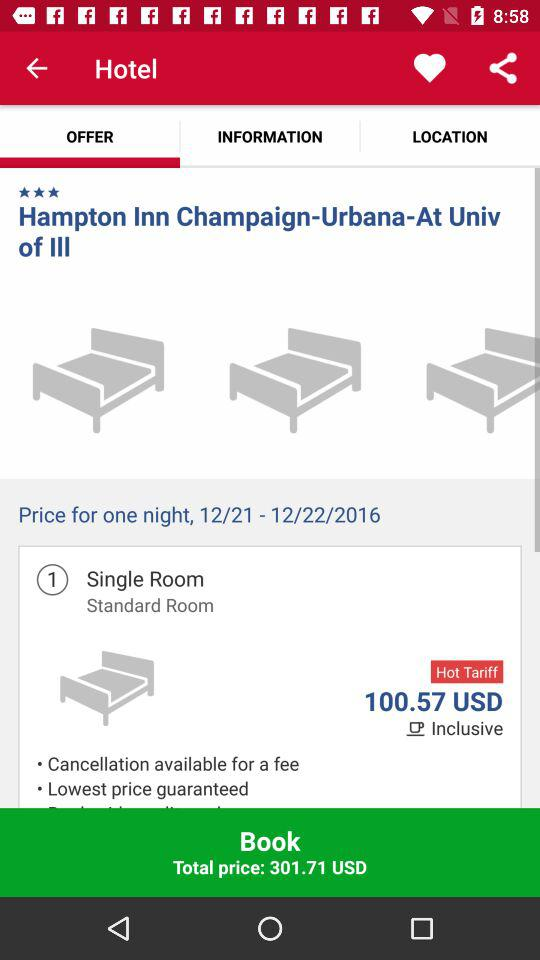How many more beds are in the Standard Room than in the Single Room?
Answer the question using a single word or phrase. 2 